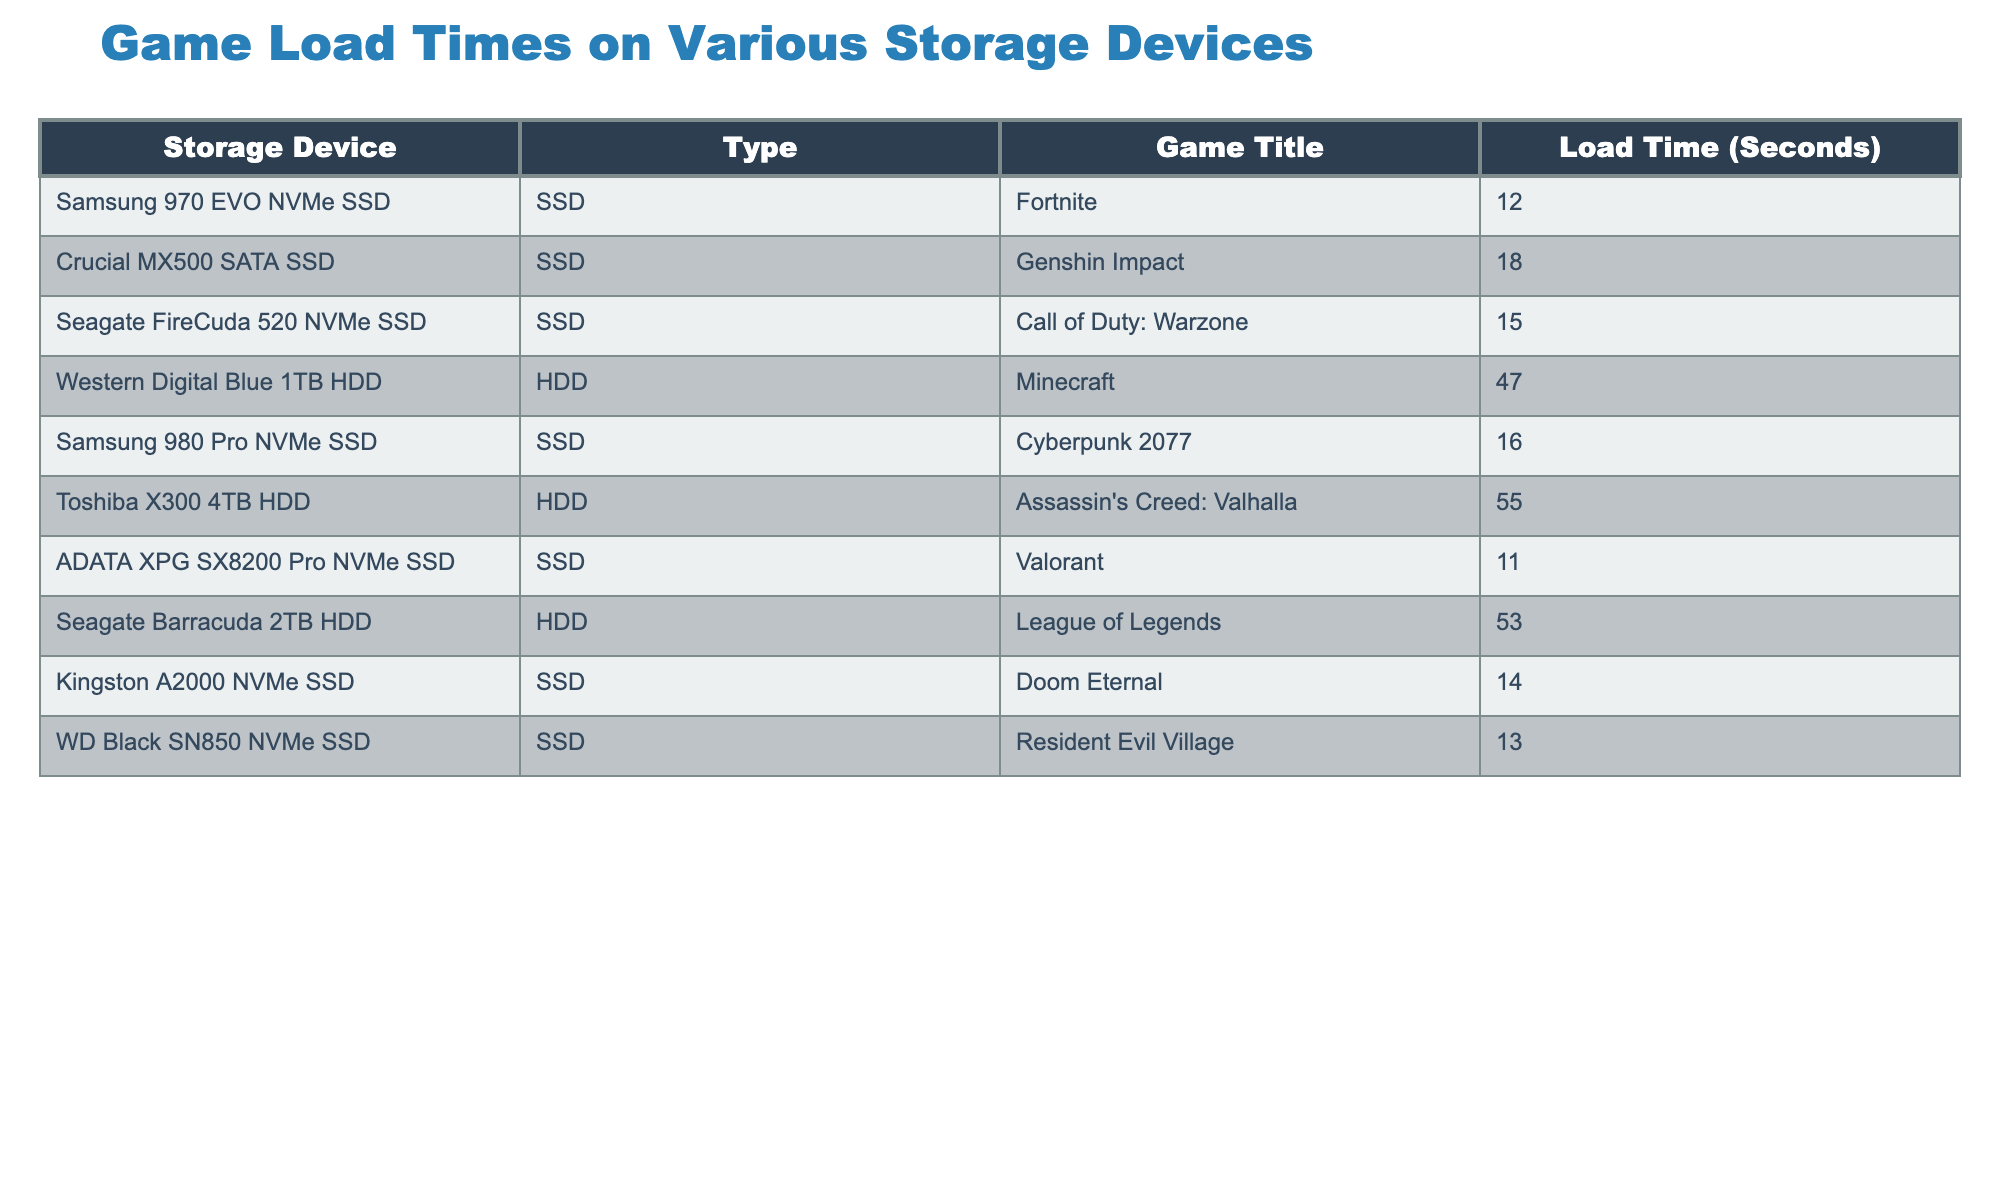What is the load time for Fortnite on the Samsung 970 EVO NVMe SSD? The table lists the game title "Fortnite," associated with the storage device, Samsung 970 EVO NVMe SSD. Under the "Load Time (Seconds)" column, the corresponding load time is 12 seconds.
Answer: 12 seconds Which game has the longest load time among the listed HDDs? In the table, the HDDs are Western Digital Blue 1TB HDD (47 seconds) and Toshiba X300 4TB HDD (55 seconds). Comparing the two, the Toshiba X300 has the longest load time of 55 seconds.
Answer: 55 seconds What is the average load time for the SSDs listed in the table? The load times for the SSDs are 12, 18, 15, 16, 11, 14, and 13 seconds. Adding these gives a total of 99 seconds. There are 7 SSDs, so the average load time is 99 seconds divided by 7, which equals approximately 14.14 seconds.
Answer: 14.14 seconds Is the load time for Cyberpunk 2077 less than 20 seconds? The table shows that the load time for Cyberpunk 2077 on the Samsung 980 Pro NVMe SSD is 16 seconds. Since 16 seconds is indeed less than 20 seconds, the answer is yes.
Answer: Yes How much faster is Valorant's load time compared to Minecraft's load time? Valorant has a load time of 11 seconds, while Minecraft's load time is 47 seconds. To find out how much faster, subtract Valorant's load time from Minecraft's: 47 seconds - 11 seconds = 36 seconds. So, Valorant is 36 seconds faster.
Answer: 36 seconds Which storage device has the shortest load time for Doom Eternal? The table indicates that Doom Eternal loads in 14 seconds on the Kingston A2000 NVMe SSD. Comparing to other listed devices and games, this is the shortest load time for Doom Eternal.
Answer: Kingston A2000 NVMe SSD How many games have load times greater than 50 seconds? The table lists two HDDs with load times above 50 seconds: Western Digital Blue 1TB HDD (47 seconds) and Toshiba X300 4TB HDD (55 seconds). Since only the Toshiba X300 exceeds 50 seconds, the count is 1 game.
Answer: 1 game What is the difference in load time between Call of Duty: Warzone and Resident Evil Village? Call of Duty: Warzone has a load time of 15 seconds, while Resident Evil Village has a load time of 13 seconds. The difference is calculated as 15 seconds - 13 seconds = 2 seconds. Therefore, Call of Duty: Warzone takes 2 seconds longer to load.
Answer: 2 seconds 